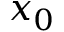Convert formula to latex. <formula><loc_0><loc_0><loc_500><loc_500>x _ { 0 }</formula> 